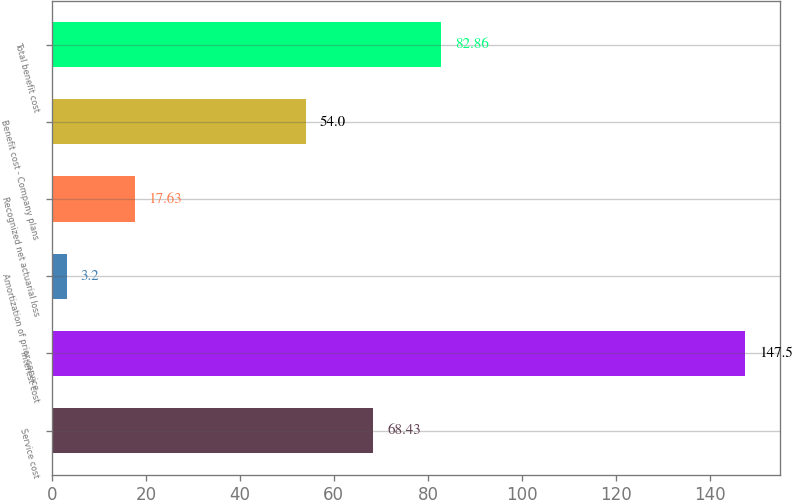<chart> <loc_0><loc_0><loc_500><loc_500><bar_chart><fcel>Service cost<fcel>Interest cost<fcel>Amortization of prior service<fcel>Recognized net actuarial loss<fcel>Benefit cost - Company plans<fcel>Total benefit cost<nl><fcel>68.43<fcel>147.5<fcel>3.2<fcel>17.63<fcel>54<fcel>82.86<nl></chart> 